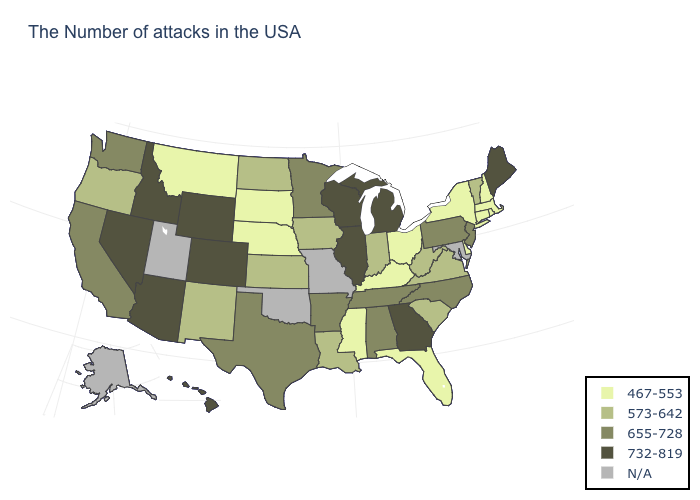What is the lowest value in states that border Idaho?
Short answer required. 467-553. What is the value of Pennsylvania?
Short answer required. 655-728. How many symbols are there in the legend?
Keep it brief. 5. Does the map have missing data?
Be succinct. Yes. What is the highest value in states that border Wisconsin?
Short answer required. 732-819. What is the value of New Mexico?
Write a very short answer. 573-642. What is the highest value in states that border Kansas?
Be succinct. 732-819. What is the highest value in the USA?
Give a very brief answer. 732-819. Among the states that border Maryland , which have the highest value?
Concise answer only. Pennsylvania. What is the value of South Dakota?
Concise answer only. 467-553. What is the lowest value in states that border Delaware?
Short answer required. 655-728. What is the value of New Jersey?
Short answer required. 655-728. Does New Jersey have the lowest value in the Northeast?
Write a very short answer. No. What is the value of Mississippi?
Answer briefly. 467-553. Which states have the highest value in the USA?
Write a very short answer. Maine, Georgia, Michigan, Wisconsin, Illinois, Wyoming, Colorado, Arizona, Idaho, Nevada, Hawaii. 